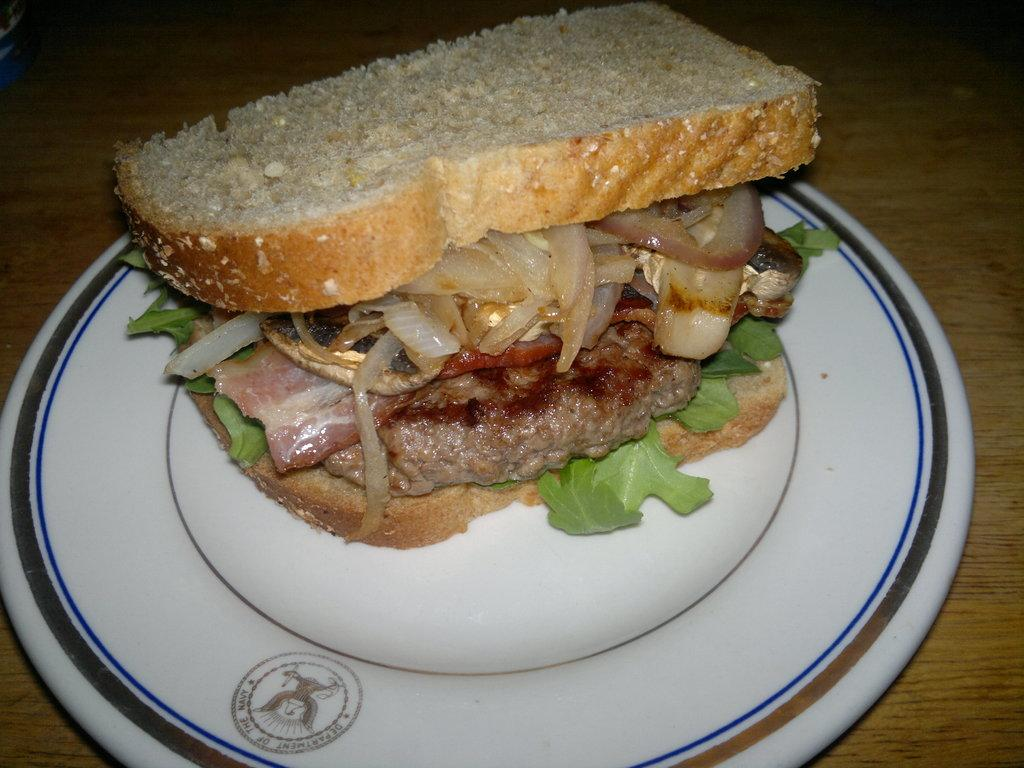What type of food is visible in the image? There is a sandwich in the image. Where is the sandwich placed? The sandwich is on a plate. What is the plate resting on? The plate is on a wooden object. What type of ink is used to write the word "discovery" on the sandwich? There is no ink or writing on the sandwich in the image. What apparatus is used to prepare the sandwich in the image? The image does not show any apparatus used to prepare the sandwich; it only shows the sandwich on a plate. 